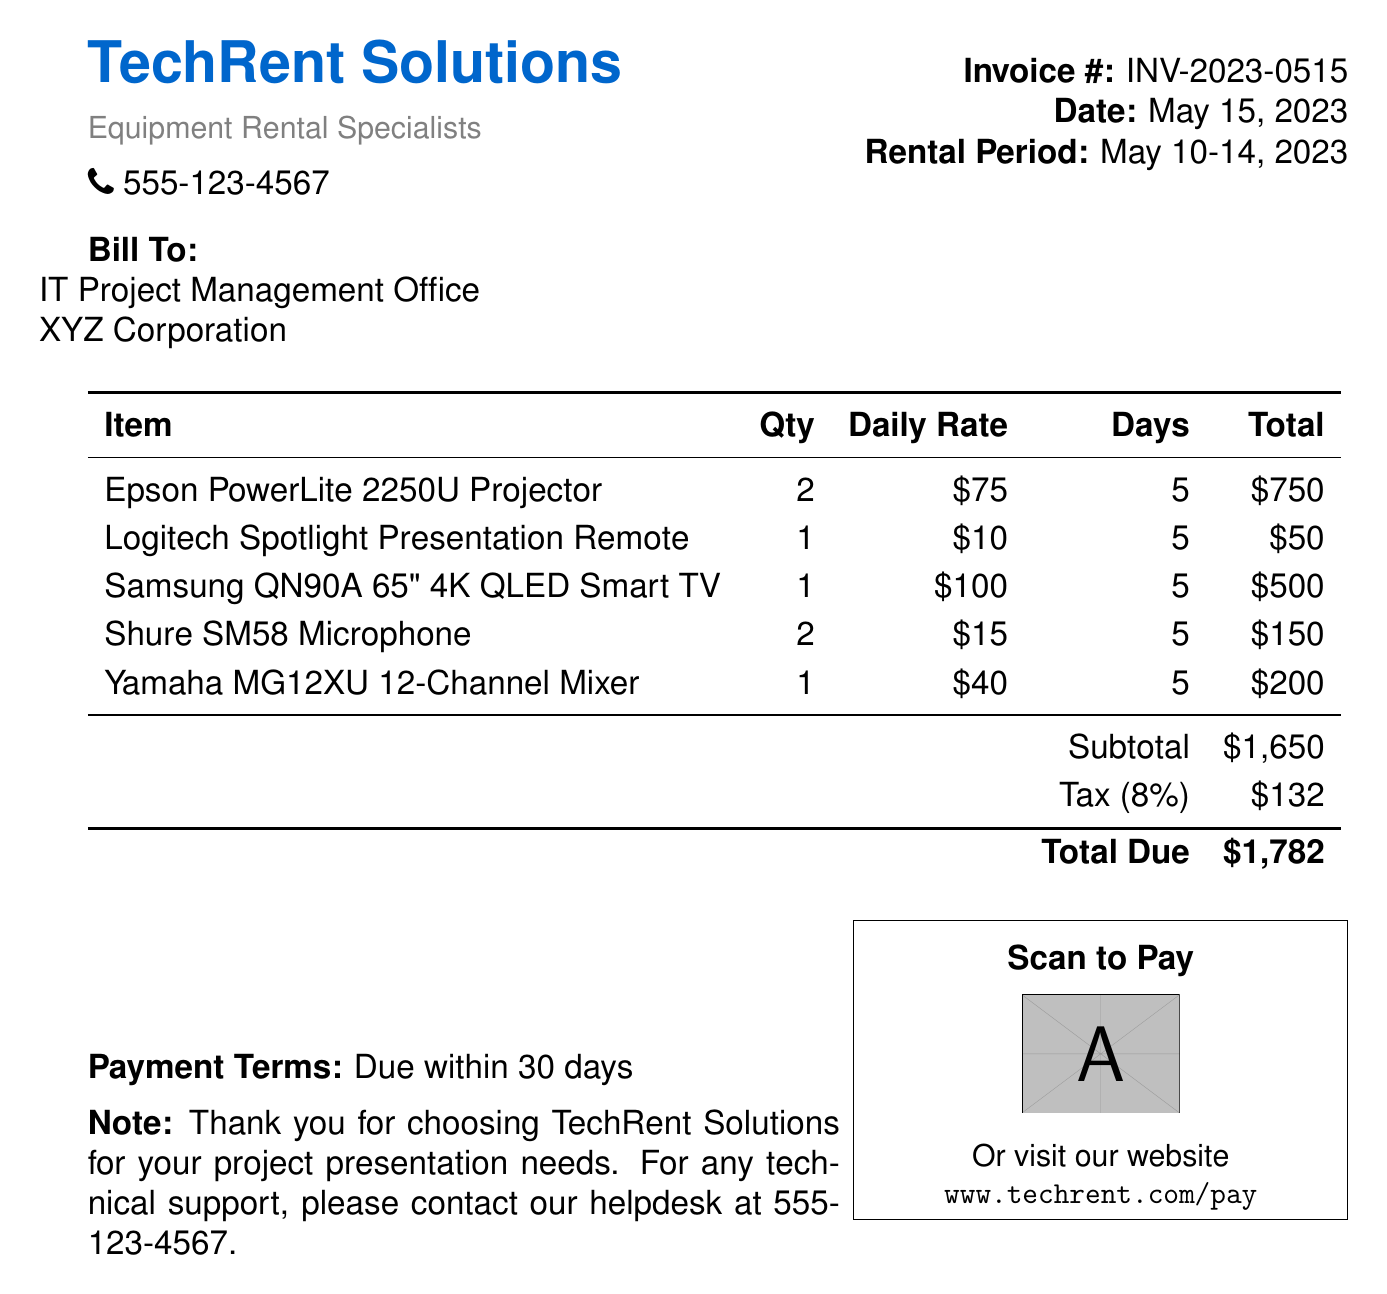What is the invoice number? The invoice number is listed at the top right corner of the document under the "Invoice #" label.
Answer: INV-2023-0515 What is the total due amount? The total due amount is found at the bottom of the itemized charges table under "Total Due."
Answer: $1,782 How many days was the rental period? The rental period is specified in the header section of the document, indicating the start and end dates.
Answer: 5 What is the quantity of Epson PowerLite 2250U Projectors rented? The quantity is listed in the itemized charges table under the "Qty" column for the Epson PowerLite 2250U Projector.
Answer: 2 What tax rate was applied to the subtotal? The tax rate is mentioned in the itemized charges table under the "Tax" line, indicating the percentage applied to the subtotal.
Answer: 8% What is the name of the company issuing the bill? The company name is presented at the top of the document in a larger font under "TechRent Solutions."
Answer: TechRent Solutions Which item had the highest daily rate? The daily rates are listed in the table, and based on these rates, you can determine which item costs the most per day.
Answer: Samsung QN90A 65" 4K QLED Smart TV What is the name of the item with the lowest total charge? By looking at the total charges in the itemized table, you can identify which item has the smallest total.
Answer: Logitech Spotlight Presentation Remote What are the payment terms specified in the document? The payment terms are mentioned in the notes section at the bottom of the bill.
Answer: Due within 30 days 